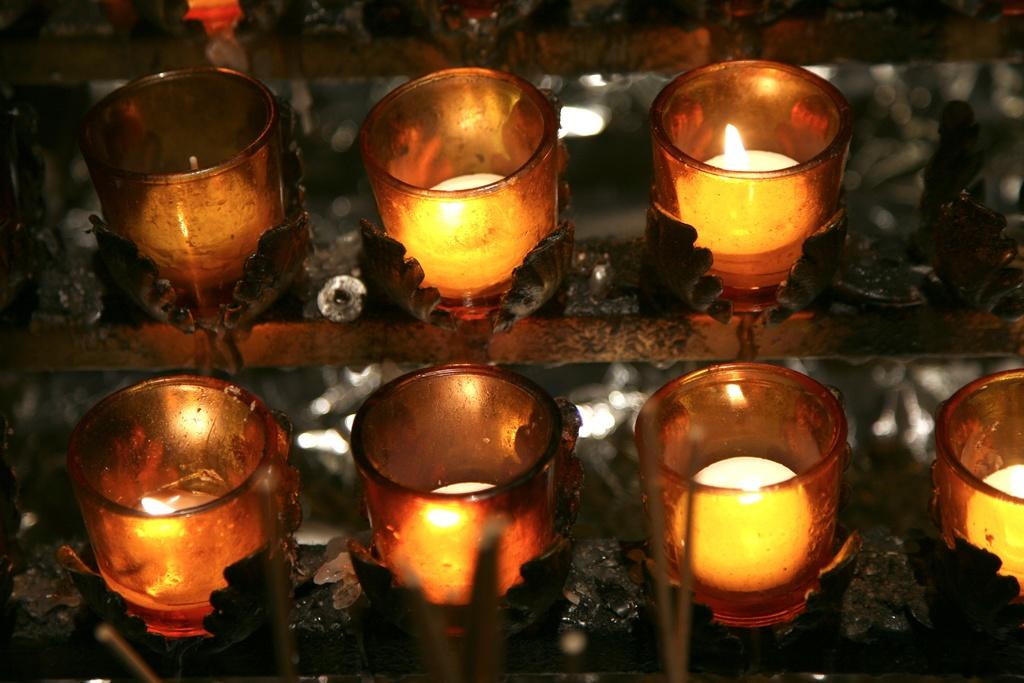What type of candles are visible in the image? There are glass candles in the image. What are the glass candles placed in? There are candle holders in the image. Where are the glass candles and candle holders located in the image? Both the glass candles and candle holders are in the foreground of the image. What type of vest is being worn by the pie in the image? There is no pie or vest present in the image; it only features glass candles and candle holders. 